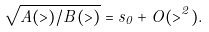Convert formula to latex. <formula><loc_0><loc_0><loc_500><loc_500>\sqrt { A ( > ) / B ( > ) } = s _ { 0 } + O ( > ^ { 2 } ) .</formula> 